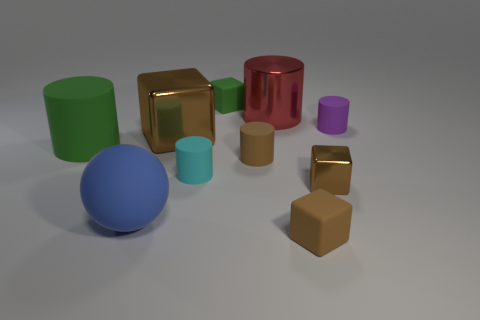Subtract all brown blocks. How many blocks are left? 1 Subtract all metallic cylinders. How many cylinders are left? 4 Subtract 1 brown cylinders. How many objects are left? 9 Subtract all spheres. How many objects are left? 9 Subtract 1 spheres. How many spheres are left? 0 Subtract all brown cylinders. Subtract all blue blocks. How many cylinders are left? 4 Subtract all yellow balls. How many green cubes are left? 1 Subtract all green rubber blocks. Subtract all balls. How many objects are left? 8 Add 9 small brown shiny cubes. How many small brown shiny cubes are left? 10 Add 2 red matte objects. How many red matte objects exist? 2 